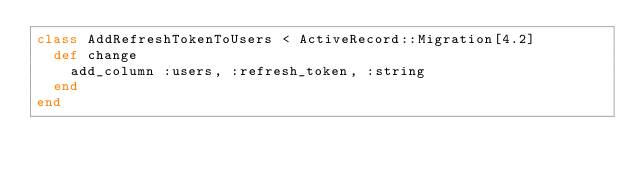Convert code to text. <code><loc_0><loc_0><loc_500><loc_500><_Ruby_>class AddRefreshTokenToUsers < ActiveRecord::Migration[4.2]
  def change
    add_column :users, :refresh_token, :string
  end
end
</code> 